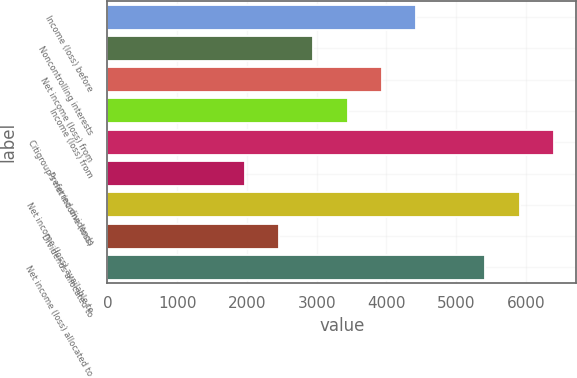Convert chart to OTSL. <chart><loc_0><loc_0><loc_500><loc_500><bar_chart><fcel>Income (loss) before<fcel>Noncontrolling interests<fcel>Net income (loss) from<fcel>Income (loss) from<fcel>Citigroup's net income (loss)<fcel>Preferred dividends<fcel>Net income (loss) available to<fcel>Dividends allocated to<fcel>Net income (loss) allocated to<nl><fcel>4431.65<fcel>2954.48<fcel>3939.26<fcel>3446.87<fcel>6401.19<fcel>1969.7<fcel>5908.8<fcel>2462.09<fcel>5416.41<nl></chart> 